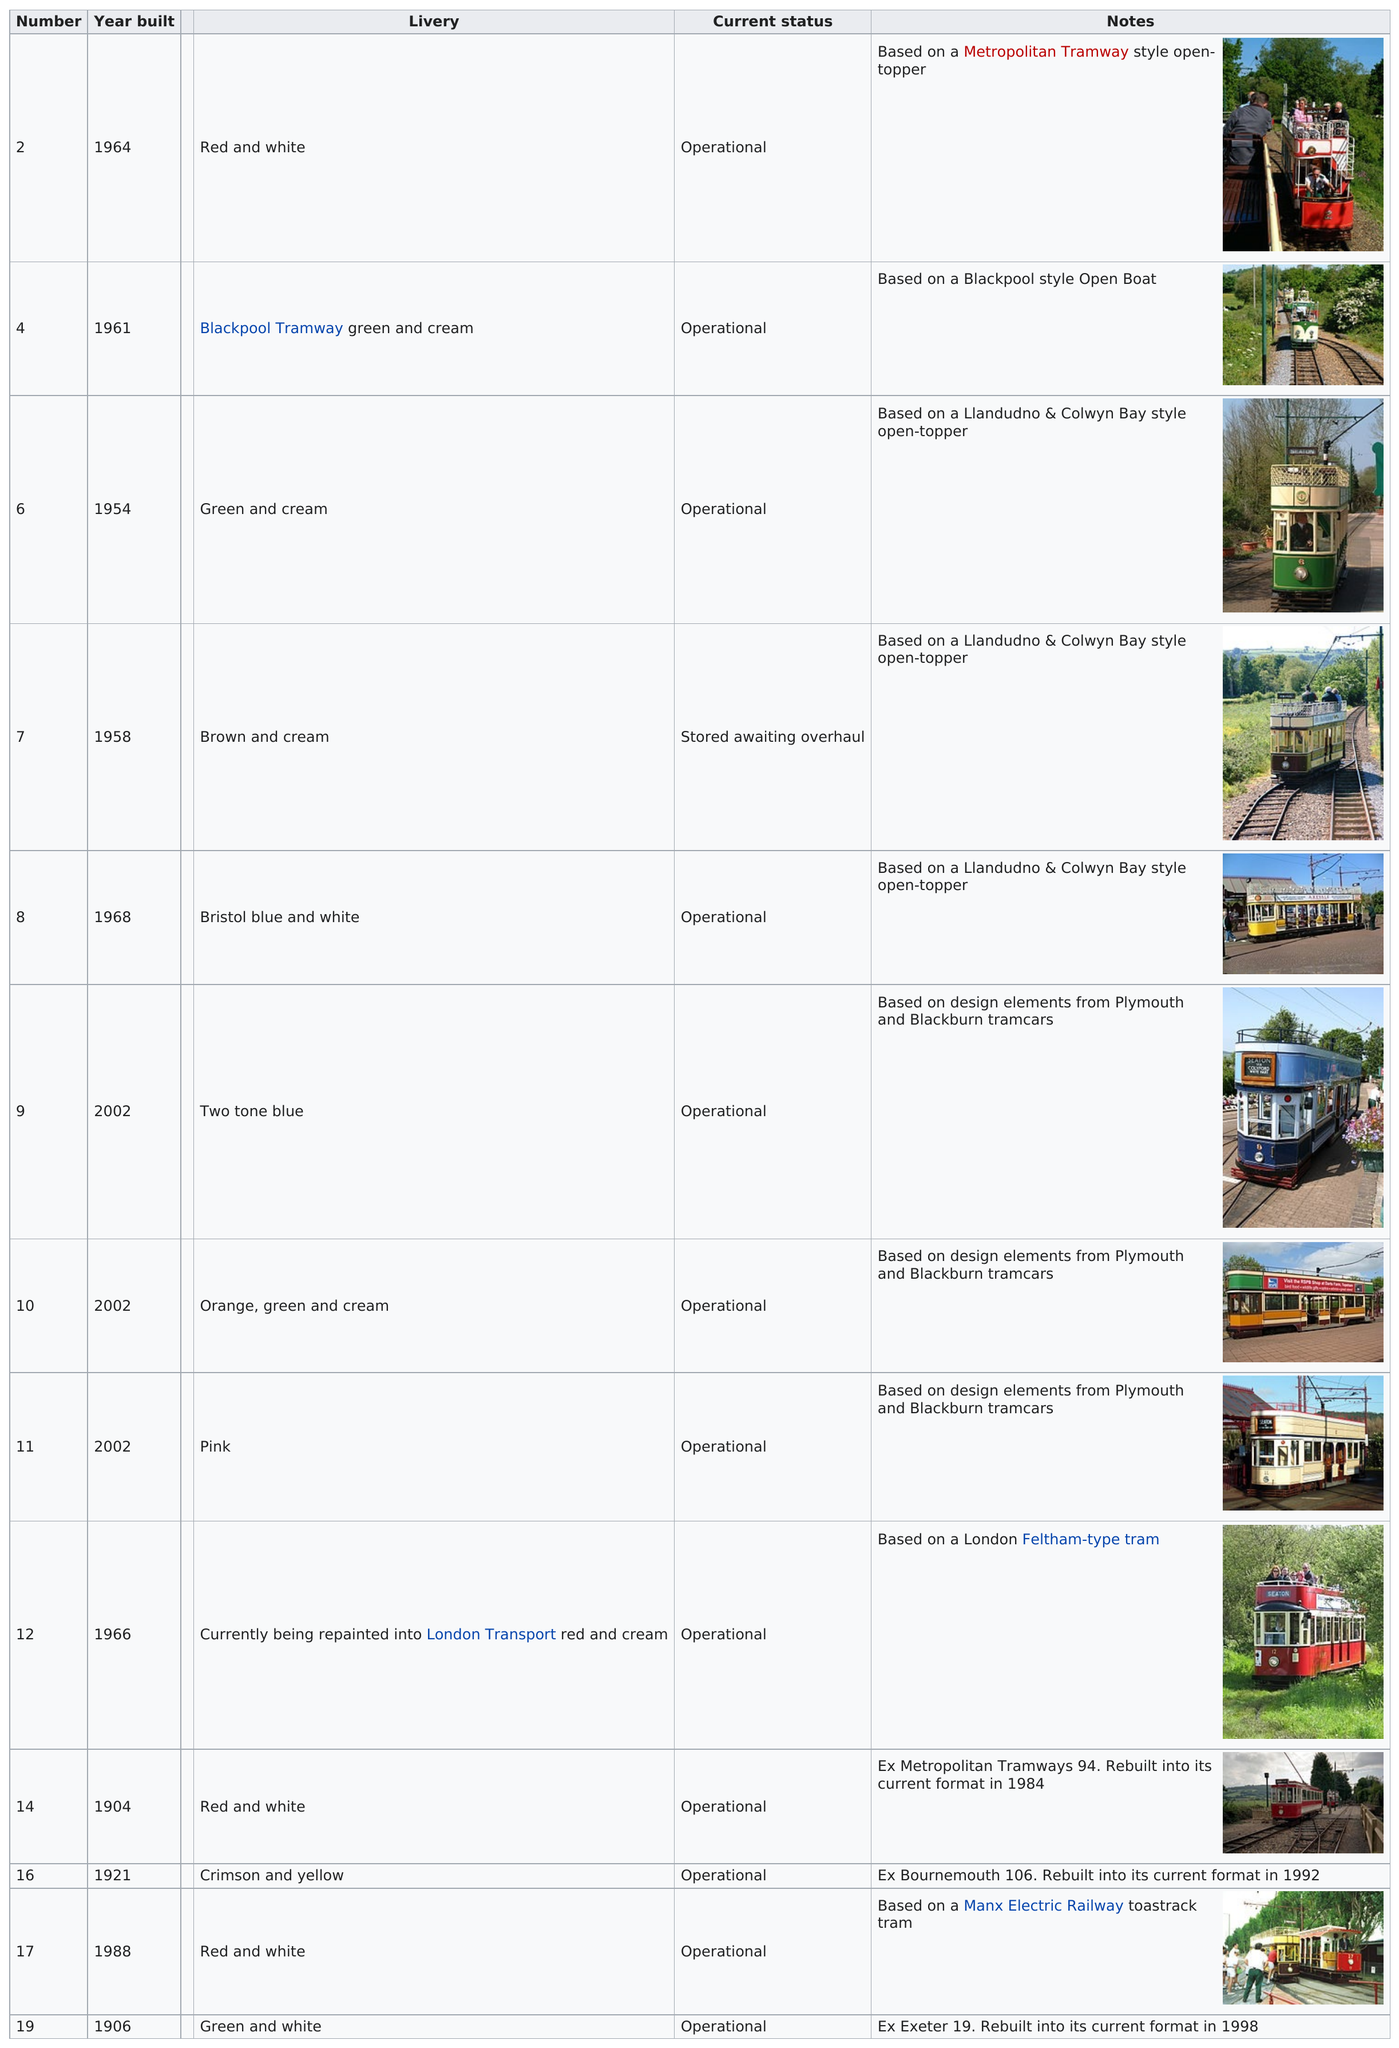Highlight a few significant elements in this photo. Of the trams that have a cream color in their livery, 5 of them can be found. The #6 tram or the #14 tram was built earlier. It is estimated that approximately 5 cars were created before 1960. Out of the 12 cars, only a few are currently operational. The livery that preceded Blackpool Tramway's green and cream color scheme was also green and cream. 